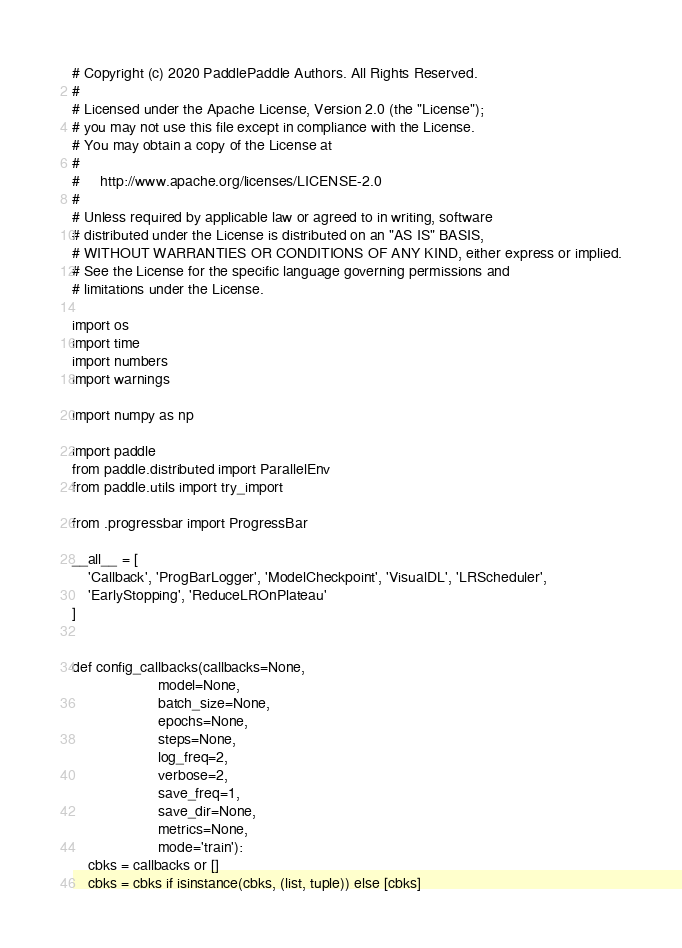<code> <loc_0><loc_0><loc_500><loc_500><_Python_># Copyright (c) 2020 PaddlePaddle Authors. All Rights Reserved.
#
# Licensed under the Apache License, Version 2.0 (the "License");
# you may not use this file except in compliance with the License.
# You may obtain a copy of the License at
#
#     http://www.apache.org/licenses/LICENSE-2.0
#
# Unless required by applicable law or agreed to in writing, software
# distributed under the License is distributed on an "AS IS" BASIS,
# WITHOUT WARRANTIES OR CONDITIONS OF ANY KIND, either express or implied.
# See the License for the specific language governing permissions and
# limitations under the License.

import os
import time
import numbers
import warnings

import numpy as np

import paddle
from paddle.distributed import ParallelEnv
from paddle.utils import try_import

from .progressbar import ProgressBar

__all__ = [
    'Callback', 'ProgBarLogger', 'ModelCheckpoint', 'VisualDL', 'LRScheduler',
    'EarlyStopping', 'ReduceLROnPlateau'
]


def config_callbacks(callbacks=None,
                     model=None,
                     batch_size=None,
                     epochs=None,
                     steps=None,
                     log_freq=2,
                     verbose=2,
                     save_freq=1,
                     save_dir=None,
                     metrics=None,
                     mode='train'):
    cbks = callbacks or []
    cbks = cbks if isinstance(cbks, (list, tuple)) else [cbks]</code> 